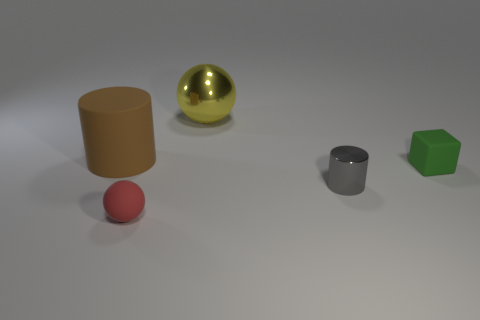How many other objects are the same material as the big ball?
Give a very brief answer. 1. The green block has what size?
Keep it short and to the point. Small. The object that is both on the right side of the brown thing and behind the tiny green matte cube is what color?
Your answer should be compact. Yellow. What number of large yellow shiny objects are there?
Your response must be concise. 1. Does the small green thing have the same material as the brown thing?
Keep it short and to the point. Yes. The tiny matte object on the left side of the sphere behind the small object that is to the left of the gray metal cylinder is what shape?
Your answer should be compact. Sphere. Is the material of the cylinder behind the small green thing the same as the ball that is on the left side of the yellow metallic object?
Your response must be concise. Yes. What material is the green block?
Keep it short and to the point. Rubber. What number of brown objects have the same shape as the green thing?
Provide a short and direct response. 0. Are there any other things that are the same shape as the small metallic thing?
Keep it short and to the point. Yes. 